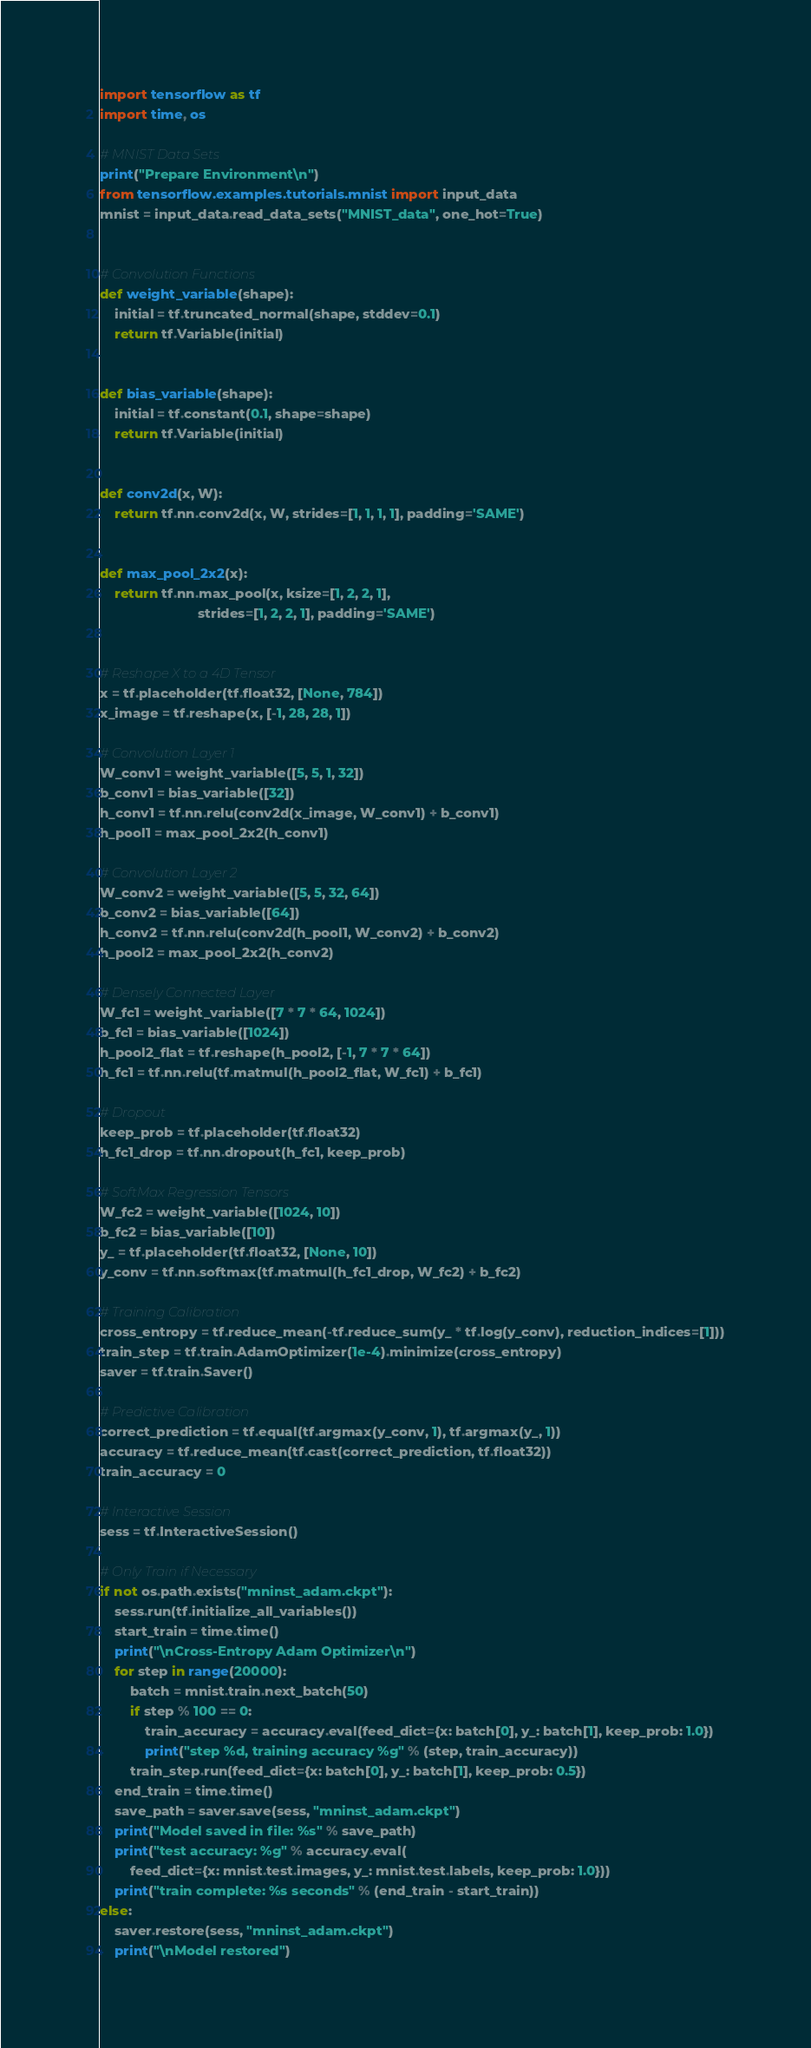Convert code to text. <code><loc_0><loc_0><loc_500><loc_500><_Python_>import tensorflow as tf
import time, os

# MNIST Data Sets
print("Prepare Environment\n")
from tensorflow.examples.tutorials.mnist import input_data
mnist = input_data.read_data_sets("MNIST_data", one_hot=True)


# Convolution Functions
def weight_variable(shape):
    initial = tf.truncated_normal(shape, stddev=0.1)
    return tf.Variable(initial)


def bias_variable(shape):
    initial = tf.constant(0.1, shape=shape)
    return tf.Variable(initial)


def conv2d(x, W):
    return tf.nn.conv2d(x, W, strides=[1, 1, 1, 1], padding='SAME')


def max_pool_2x2(x):
    return tf.nn.max_pool(x, ksize=[1, 2, 2, 1],
                          strides=[1, 2, 2, 1], padding='SAME')


# Reshape X to a 4D Tensor
x = tf.placeholder(tf.float32, [None, 784])
x_image = tf.reshape(x, [-1, 28, 28, 1])

# Convolution Layer 1
W_conv1 = weight_variable([5, 5, 1, 32])
b_conv1 = bias_variable([32])
h_conv1 = tf.nn.relu(conv2d(x_image, W_conv1) + b_conv1)
h_pool1 = max_pool_2x2(h_conv1)

# Convolution Layer 2
W_conv2 = weight_variable([5, 5, 32, 64])
b_conv2 = bias_variable([64])
h_conv2 = tf.nn.relu(conv2d(h_pool1, W_conv2) + b_conv2)
h_pool2 = max_pool_2x2(h_conv2)

# Densely Connected Layer
W_fc1 = weight_variable([7 * 7 * 64, 1024])
b_fc1 = bias_variable([1024])
h_pool2_flat = tf.reshape(h_pool2, [-1, 7 * 7 * 64])
h_fc1 = tf.nn.relu(tf.matmul(h_pool2_flat, W_fc1) + b_fc1)

# Dropout
keep_prob = tf.placeholder(tf.float32)
h_fc1_drop = tf.nn.dropout(h_fc1, keep_prob)

# SoftMax Regression Tensors
W_fc2 = weight_variable([1024, 10])
b_fc2 = bias_variable([10])
y_ = tf.placeholder(tf.float32, [None, 10])
y_conv = tf.nn.softmax(tf.matmul(h_fc1_drop, W_fc2) + b_fc2)

# Training Calibration
cross_entropy = tf.reduce_mean(-tf.reduce_sum(y_ * tf.log(y_conv), reduction_indices=[1]))
train_step = tf.train.AdamOptimizer(1e-4).minimize(cross_entropy)
saver = tf.train.Saver()

# Predictive Calibration
correct_prediction = tf.equal(tf.argmax(y_conv, 1), tf.argmax(y_, 1))
accuracy = tf.reduce_mean(tf.cast(correct_prediction, tf.float32))
train_accuracy = 0

# Interactive Session
sess = tf.InteractiveSession()

# Only Train if Necessary
if not os.path.exists("mninst_adam.ckpt"):
    sess.run(tf.initialize_all_variables())
    start_train = time.time()
    print("\nCross-Entropy Adam Optimizer\n")
    for step in range(20000):
        batch = mnist.train.next_batch(50)
        if step % 100 == 0:
            train_accuracy = accuracy.eval(feed_dict={x: batch[0], y_: batch[1], keep_prob: 1.0})
            print("step %d, training accuracy %g" % (step, train_accuracy))
        train_step.run(feed_dict={x: batch[0], y_: batch[1], keep_prob: 0.5})
    end_train = time.time()
    save_path = saver.save(sess, "mninst_adam.ckpt")
    print("Model saved in file: %s" % save_path)
    print("test accuracy: %g" % accuracy.eval(
        feed_dict={x: mnist.test.images, y_: mnist.test.labels, keep_prob: 1.0}))
    print("train complete: %s seconds" % (end_train - start_train))
else:
    saver.restore(sess, "mninst_adam.ckpt")
    print("\nModel restored")

</code> 